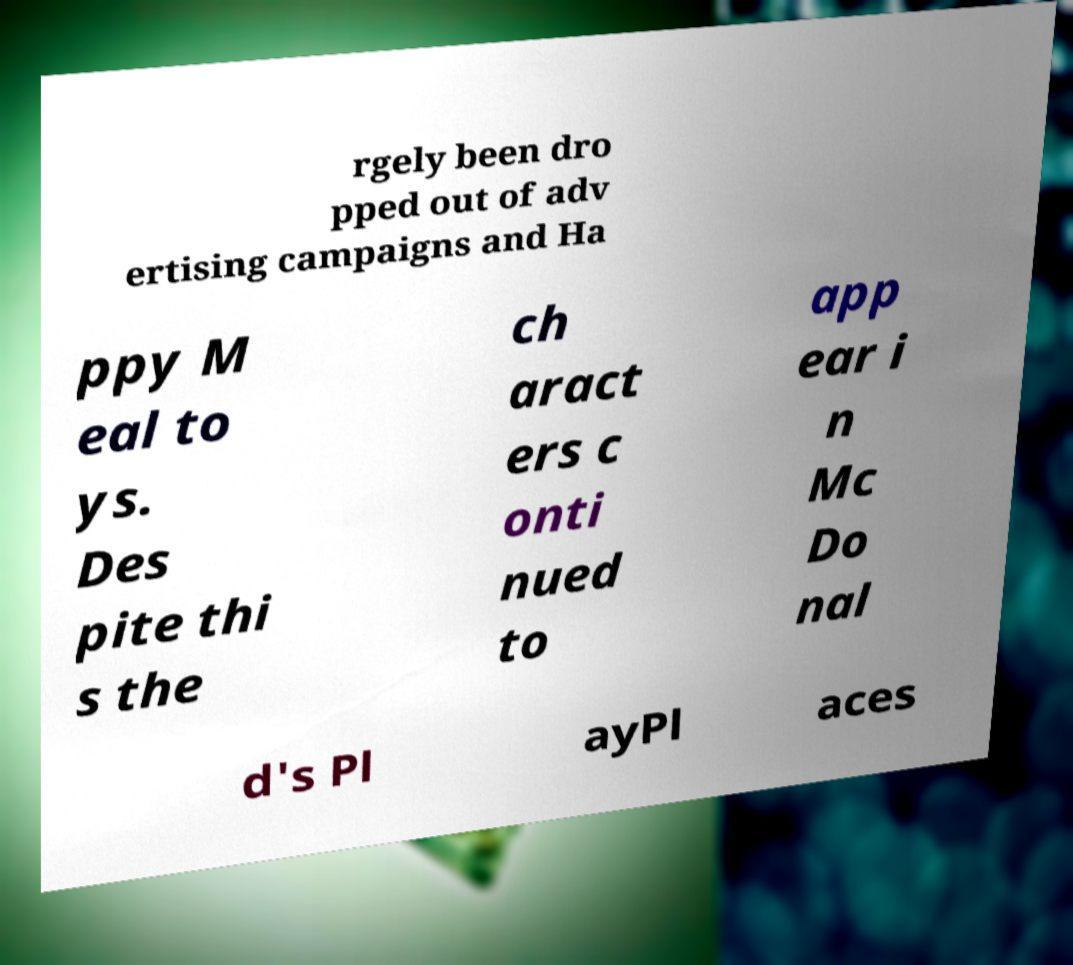Can you read and provide the text displayed in the image?This photo seems to have some interesting text. Can you extract and type it out for me? rgely been dro pped out of adv ertising campaigns and Ha ppy M eal to ys. Des pite thi s the ch aract ers c onti nued to app ear i n Mc Do nal d's Pl ayPl aces 